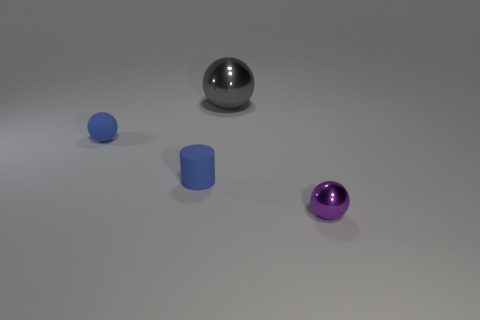How many things are gray things or tiny things?
Offer a very short reply. 4. Is the big metal thing the same shape as the purple thing?
Provide a succinct answer. Yes. Is there a thing made of the same material as the small blue cylinder?
Make the answer very short. Yes. There is a small object right of the big metal sphere; are there any metal spheres that are to the left of it?
Your answer should be very brief. Yes. Is the size of the metallic ball that is behind the blue cylinder the same as the purple thing?
Provide a succinct answer. No. How big is the gray ball?
Provide a short and direct response. Large. Are there any other tiny spheres that have the same color as the tiny rubber ball?
Provide a short and direct response. No. How many tiny objects are yellow cylinders or matte spheres?
Your answer should be very brief. 1. What size is the ball that is in front of the gray shiny sphere and behind the rubber cylinder?
Keep it short and to the point. Small. How many large gray objects are right of the blue ball?
Your answer should be compact. 1. 